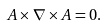<formula> <loc_0><loc_0><loc_500><loc_500>A \times \nabla \times A = 0 .</formula> 